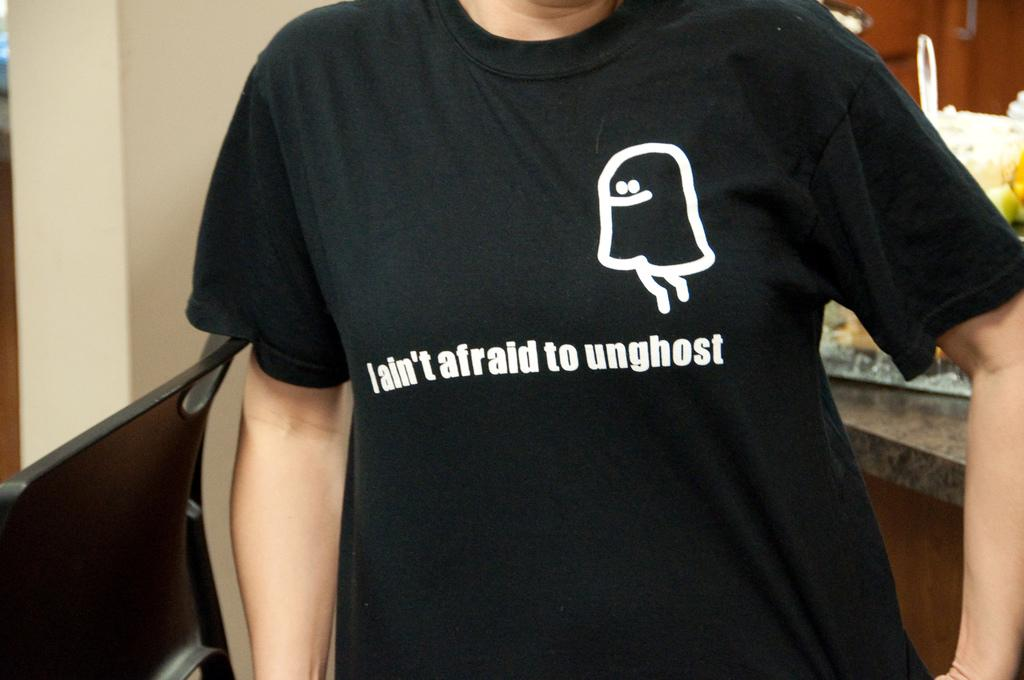Provide a one-sentence caption for the provided image. A black t-shirts states, "I ain't afraid to unghost". 